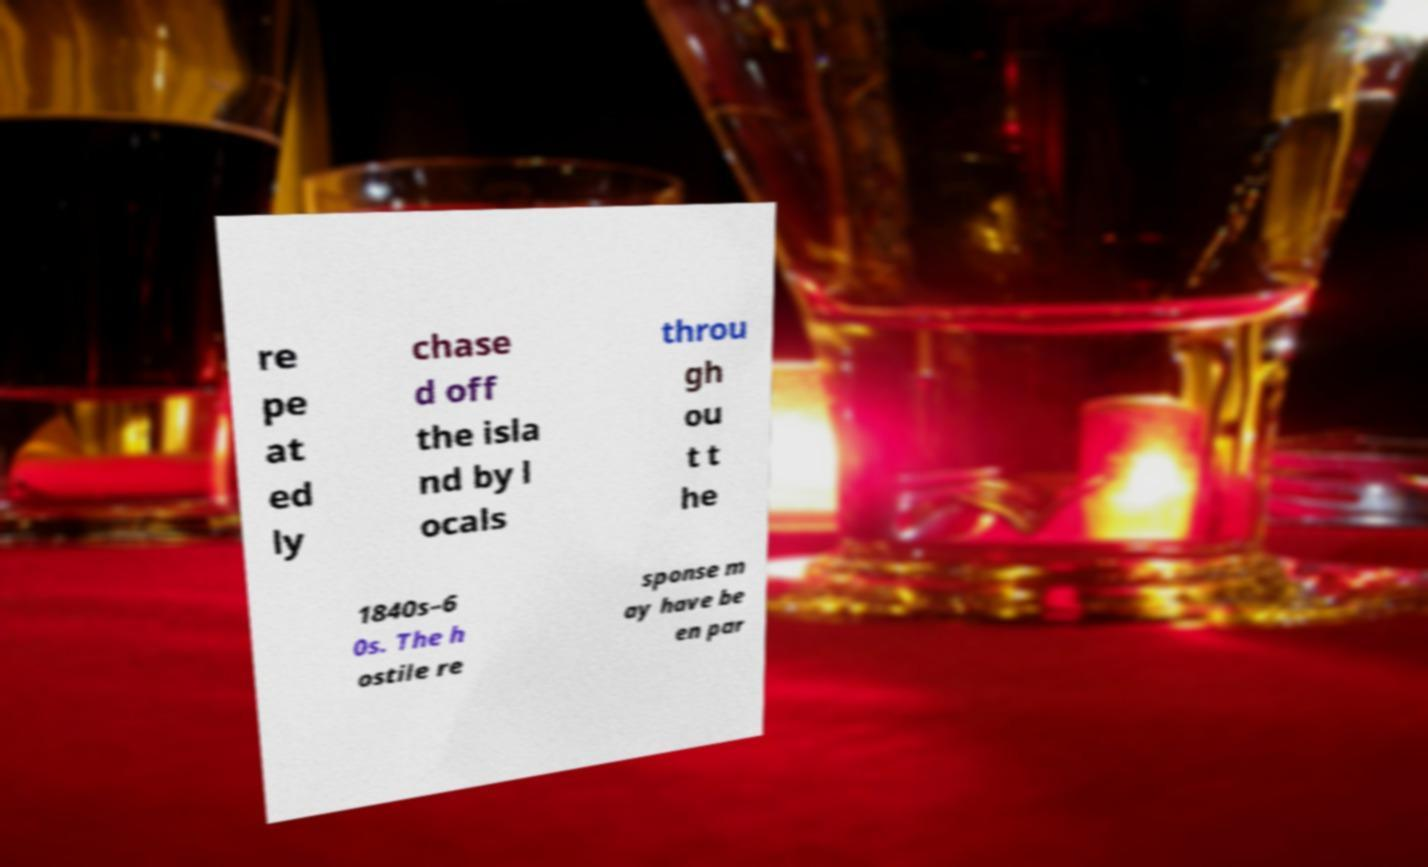Could you extract and type out the text from this image? re pe at ed ly chase d off the isla nd by l ocals throu gh ou t t he 1840s–6 0s. The h ostile re sponse m ay have be en par 